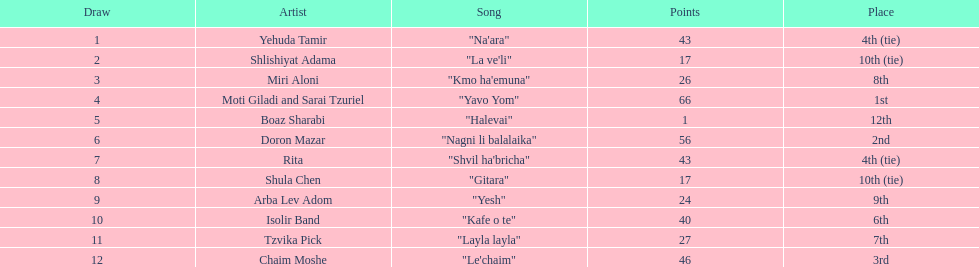In the competition, who was the artist with the minimum points? Boaz Sharabi. 